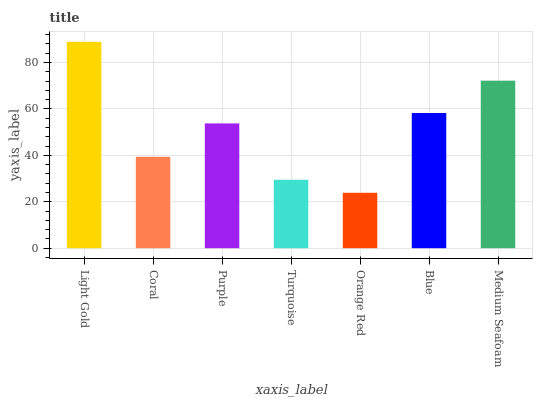Is Orange Red the minimum?
Answer yes or no. Yes. Is Light Gold the maximum?
Answer yes or no. Yes. Is Coral the minimum?
Answer yes or no. No. Is Coral the maximum?
Answer yes or no. No. Is Light Gold greater than Coral?
Answer yes or no. Yes. Is Coral less than Light Gold?
Answer yes or no. Yes. Is Coral greater than Light Gold?
Answer yes or no. No. Is Light Gold less than Coral?
Answer yes or no. No. Is Purple the high median?
Answer yes or no. Yes. Is Purple the low median?
Answer yes or no. Yes. Is Turquoise the high median?
Answer yes or no. No. Is Turquoise the low median?
Answer yes or no. No. 